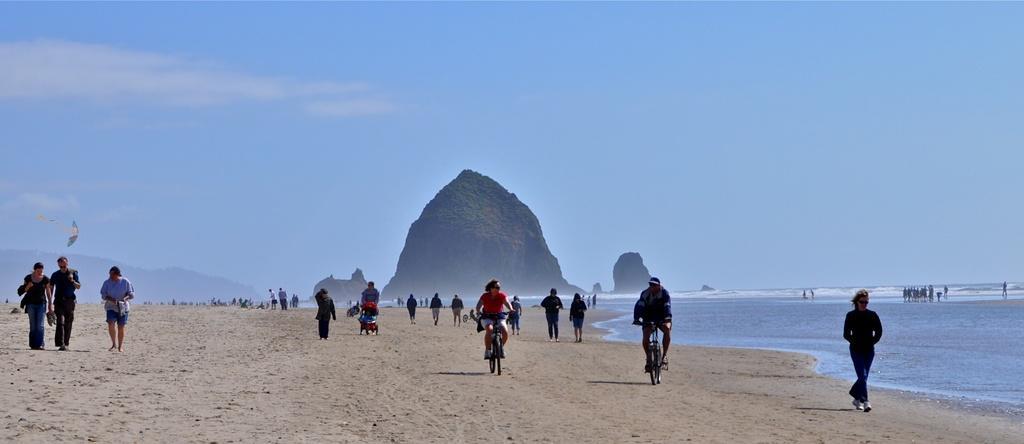Could you give a brief overview of what you see in this image? In this picture we can see some persons are walking and some of them are riding bicycles. In the center of the image we can see the mountains. On the right side of the image we can see the ocean. On the left side of the image we can see the soil. At the top of the image we can see the clouds are present in the sky. On the left side of the image we can see a flag. In the middle of the image we can see a trolley. 